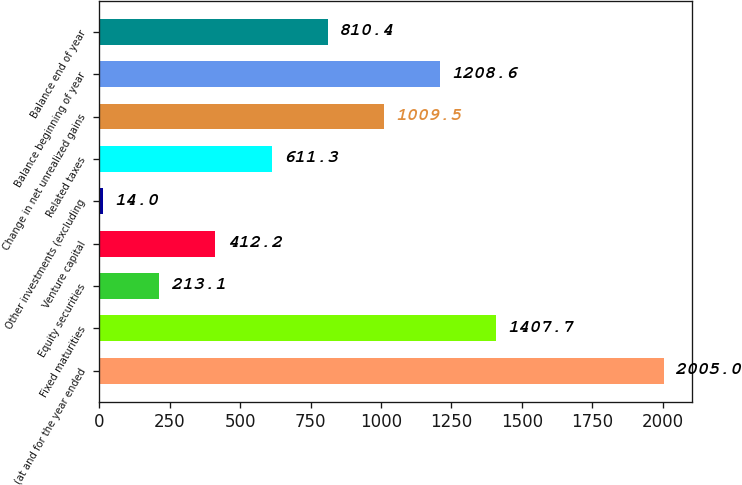Convert chart. <chart><loc_0><loc_0><loc_500><loc_500><bar_chart><fcel>(at and for the year ended<fcel>Fixed maturities<fcel>Equity securities<fcel>Venture capital<fcel>Other investments (excluding<fcel>Related taxes<fcel>Change in net unrealized gains<fcel>Balance beginning of year<fcel>Balance end of year<nl><fcel>2005<fcel>1407.7<fcel>213.1<fcel>412.2<fcel>14<fcel>611.3<fcel>1009.5<fcel>1208.6<fcel>810.4<nl></chart> 